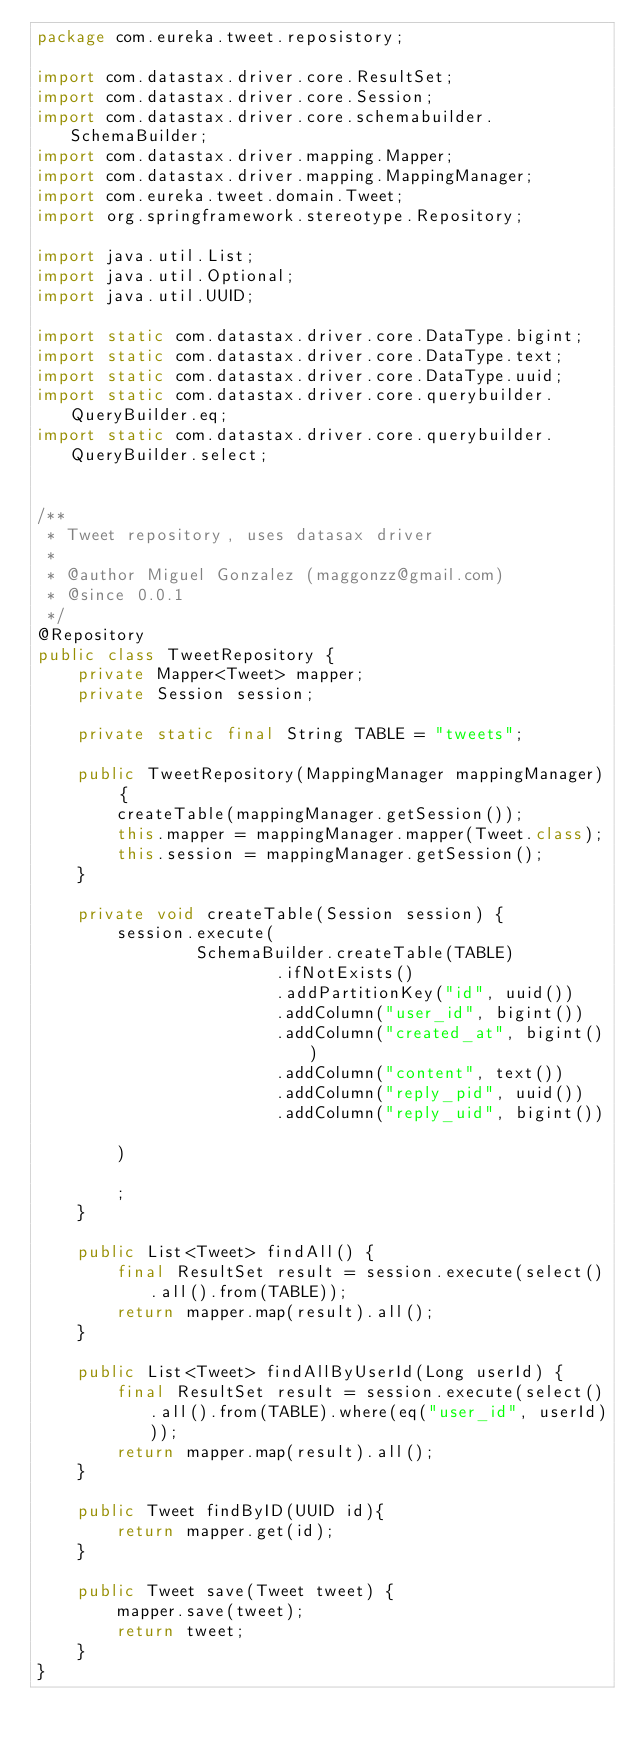Convert code to text. <code><loc_0><loc_0><loc_500><loc_500><_Java_>package com.eureka.tweet.reposistory;

import com.datastax.driver.core.ResultSet;
import com.datastax.driver.core.Session;
import com.datastax.driver.core.schemabuilder.SchemaBuilder;
import com.datastax.driver.mapping.Mapper;
import com.datastax.driver.mapping.MappingManager;
import com.eureka.tweet.domain.Tweet;
import org.springframework.stereotype.Repository;

import java.util.List;
import java.util.Optional;
import java.util.UUID;

import static com.datastax.driver.core.DataType.bigint;
import static com.datastax.driver.core.DataType.text;
import static com.datastax.driver.core.DataType.uuid;
import static com.datastax.driver.core.querybuilder.QueryBuilder.eq;
import static com.datastax.driver.core.querybuilder.QueryBuilder.select;


/**
 * Tweet repository, uses datasax driver
 *
 * @author Miguel Gonzalez (maggonzz@gmail.com)
 * @since 0.0.1
 */
@Repository
public class TweetRepository {
    private Mapper<Tweet> mapper;
    private Session session;

    private static final String TABLE = "tweets";

    public TweetRepository(MappingManager mappingManager) {
        createTable(mappingManager.getSession());
        this.mapper = mappingManager.mapper(Tweet.class);
        this.session = mappingManager.getSession();
    }

    private void createTable(Session session) {
        session.execute(
                SchemaBuilder.createTable(TABLE)
                        .ifNotExists()
                        .addPartitionKey("id", uuid())
                        .addColumn("user_id", bigint())
                        .addColumn("created_at", bigint())
                        .addColumn("content", text())
                        .addColumn("reply_pid", uuid())
                        .addColumn("reply_uid", bigint())

        )

        ;
    }

    public List<Tweet> findAll() {
        final ResultSet result = session.execute(select().all().from(TABLE));
        return mapper.map(result).all();
    }

    public List<Tweet> findAllByUserId(Long userId) {
        final ResultSet result = session.execute(select().all().from(TABLE).where(eq("user_id", userId)));
        return mapper.map(result).all();
    }

    public Tweet findByID(UUID id){
        return mapper.get(id);
    }

    public Tweet save(Tweet tweet) {
        mapper.save(tweet);
        return tweet;
    }
}
</code> 